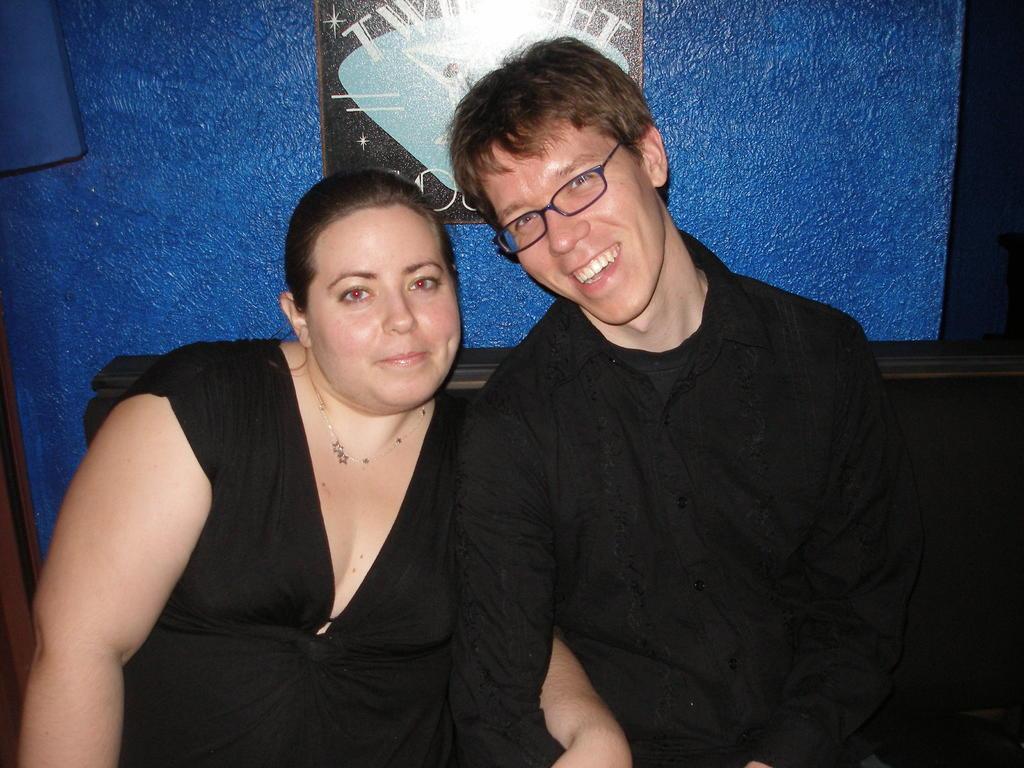Describe this image in one or two sentences. In this image, there are two persons sitting on a couch. In the background, I can see a photo frame attached to the wall. 